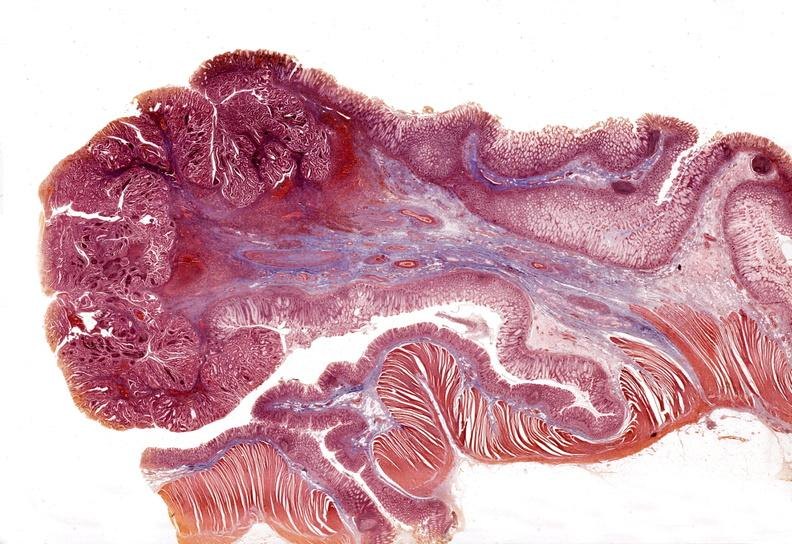what does this image show?
Answer the question using a single word or phrase. Stomach 